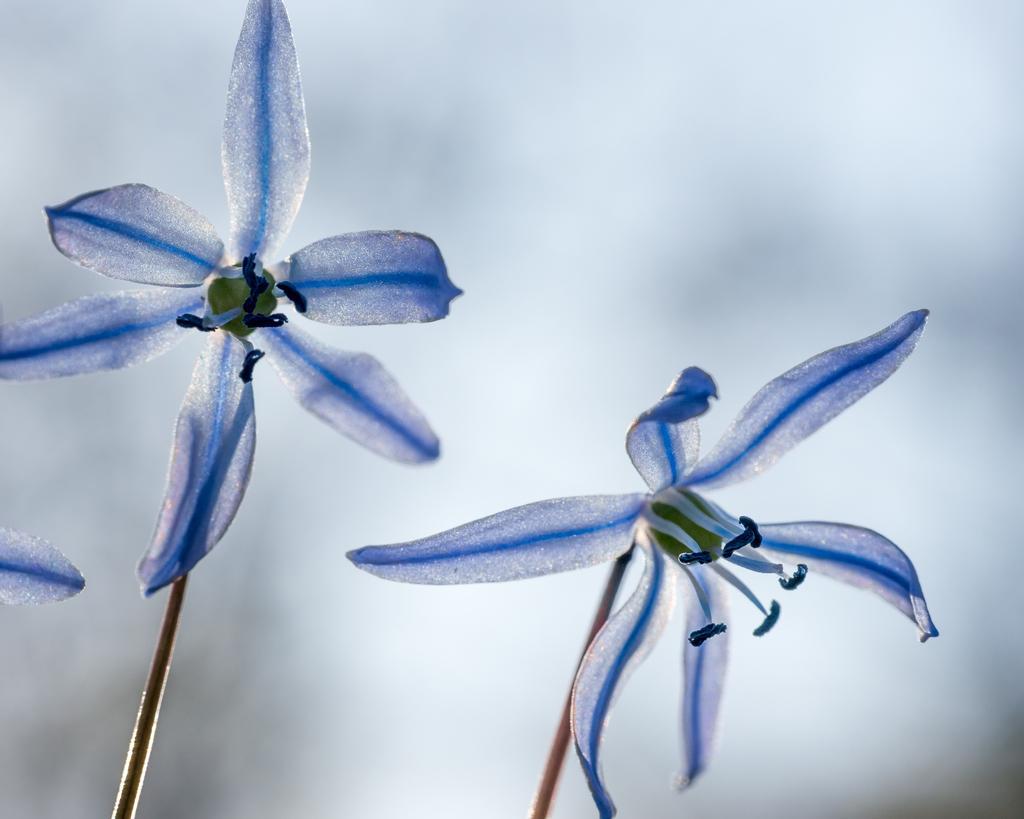In one or two sentences, can you explain what this image depicts? In this picture there are two flowers which are in white and blue color and there is a green color object in between it. 